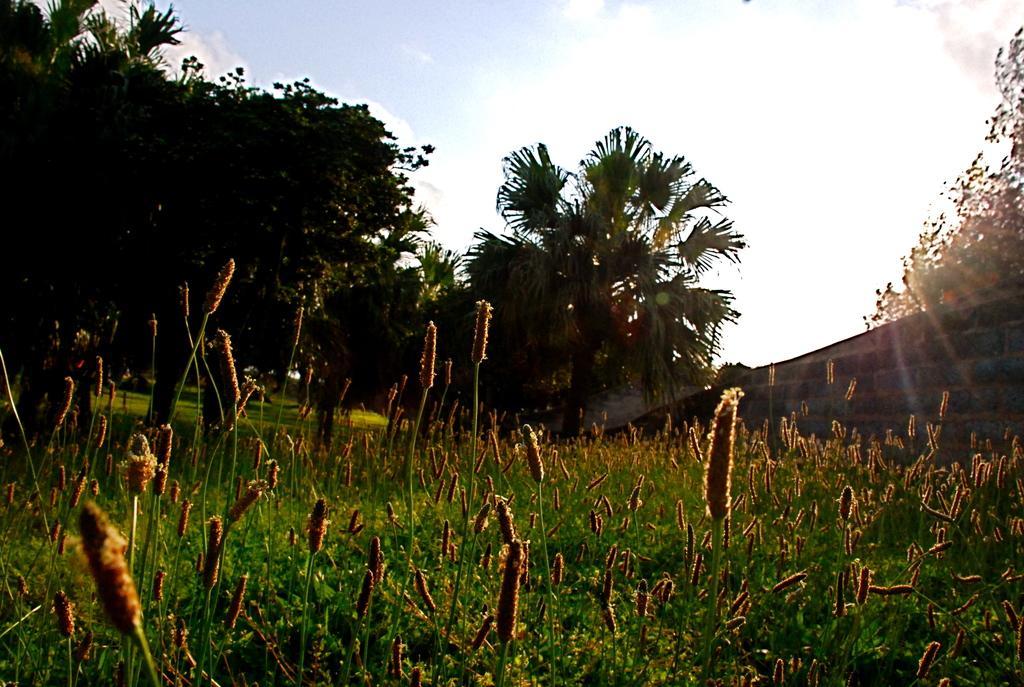Please provide a concise description of this image. In the image in the center we can see grass. In the background we can see the sky,clouds,trees,grass and wall. 